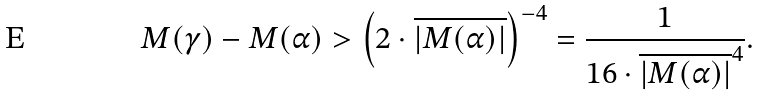<formula> <loc_0><loc_0><loc_500><loc_500>M ( \gamma ) - M ( \alpha ) > \left ( 2 \cdot \overline { | M ( \alpha ) | } \right ) ^ { - 4 } = \frac { 1 } { 1 6 \cdot \overline { | M ( \alpha ) | } ^ { 4 } } .</formula> 